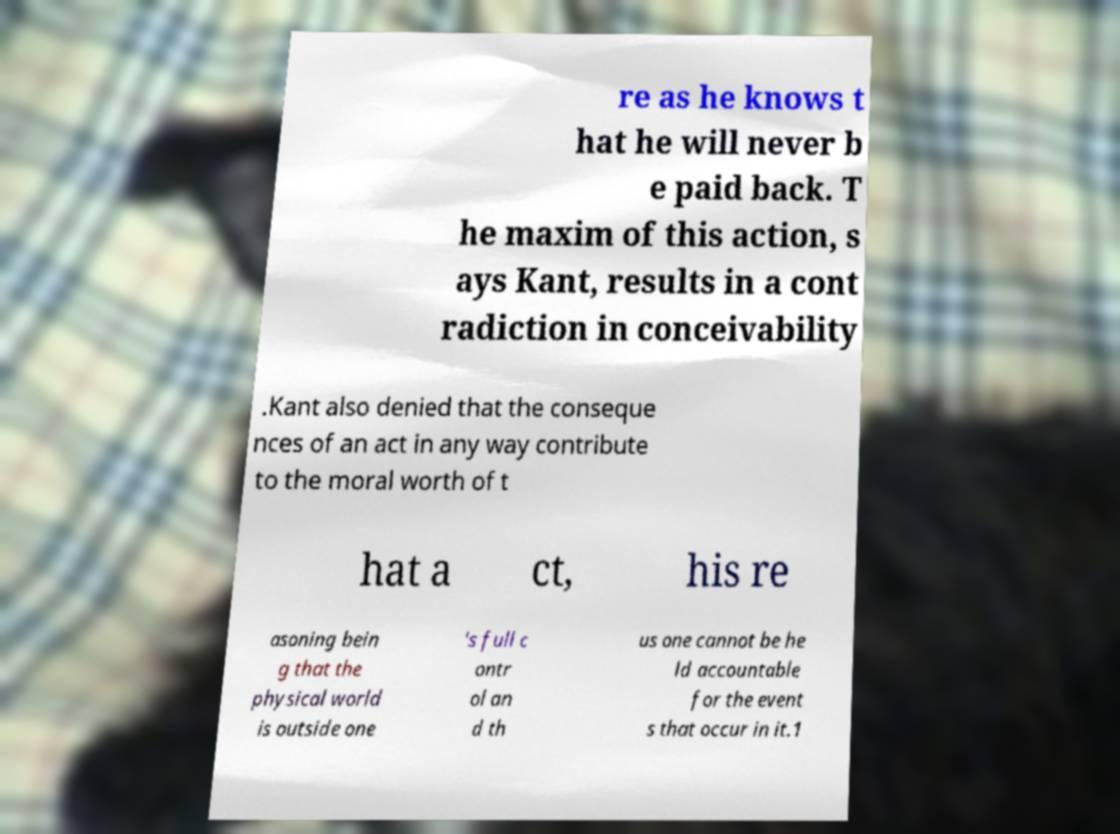Could you extract and type out the text from this image? re as he knows t hat he will never b e paid back. T he maxim of this action, s ays Kant, results in a cont radiction in conceivability .Kant also denied that the conseque nces of an act in any way contribute to the moral worth of t hat a ct, his re asoning bein g that the physical world is outside one 's full c ontr ol an d th us one cannot be he ld accountable for the event s that occur in it.1 